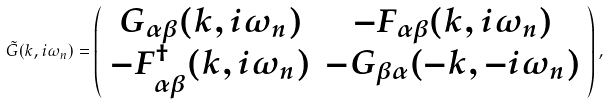Convert formula to latex. <formula><loc_0><loc_0><loc_500><loc_500>\tilde { G } ( { k } , i \omega _ { n } ) = \left ( \begin{array} { c c } G _ { \alpha \beta } ( { k } , i \omega _ { n } ) & - F _ { \alpha \beta } ( { k } , i \omega _ { n } ) \\ - F _ { \alpha \beta } ^ { \dagger } ( { k } , i \omega _ { n } ) & - G _ { \beta \alpha } ( - { k } , - i \omega _ { n } ) \\ \end{array} \right ) ,</formula> 